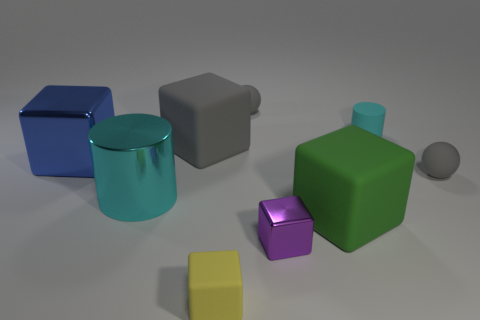How many small things are green metallic cylinders or gray blocks?
Provide a short and direct response. 0. Does the purple object have the same material as the large cylinder?
Your answer should be very brief. Yes. There is a thing that is the same color as the tiny rubber cylinder; what is its size?
Offer a very short reply. Large. Is there a ball that has the same color as the tiny rubber cube?
Offer a very short reply. No. What size is the purple block that is the same material as the big cyan cylinder?
Your answer should be compact. Small. What is the shape of the thing left of the cyan thing to the left of the tiny rubber thing that is in front of the tiny purple thing?
Your answer should be very brief. Cube. There is a gray thing that is the same shape as the small yellow thing; what is its size?
Provide a succinct answer. Large. How big is the block that is right of the small yellow rubber block and behind the tiny metal object?
Ensure brevity in your answer.  Large. What color is the tiny rubber block?
Make the answer very short. Yellow. There is a gray sphere that is right of the tiny cyan rubber thing; how big is it?
Make the answer very short. Small. 